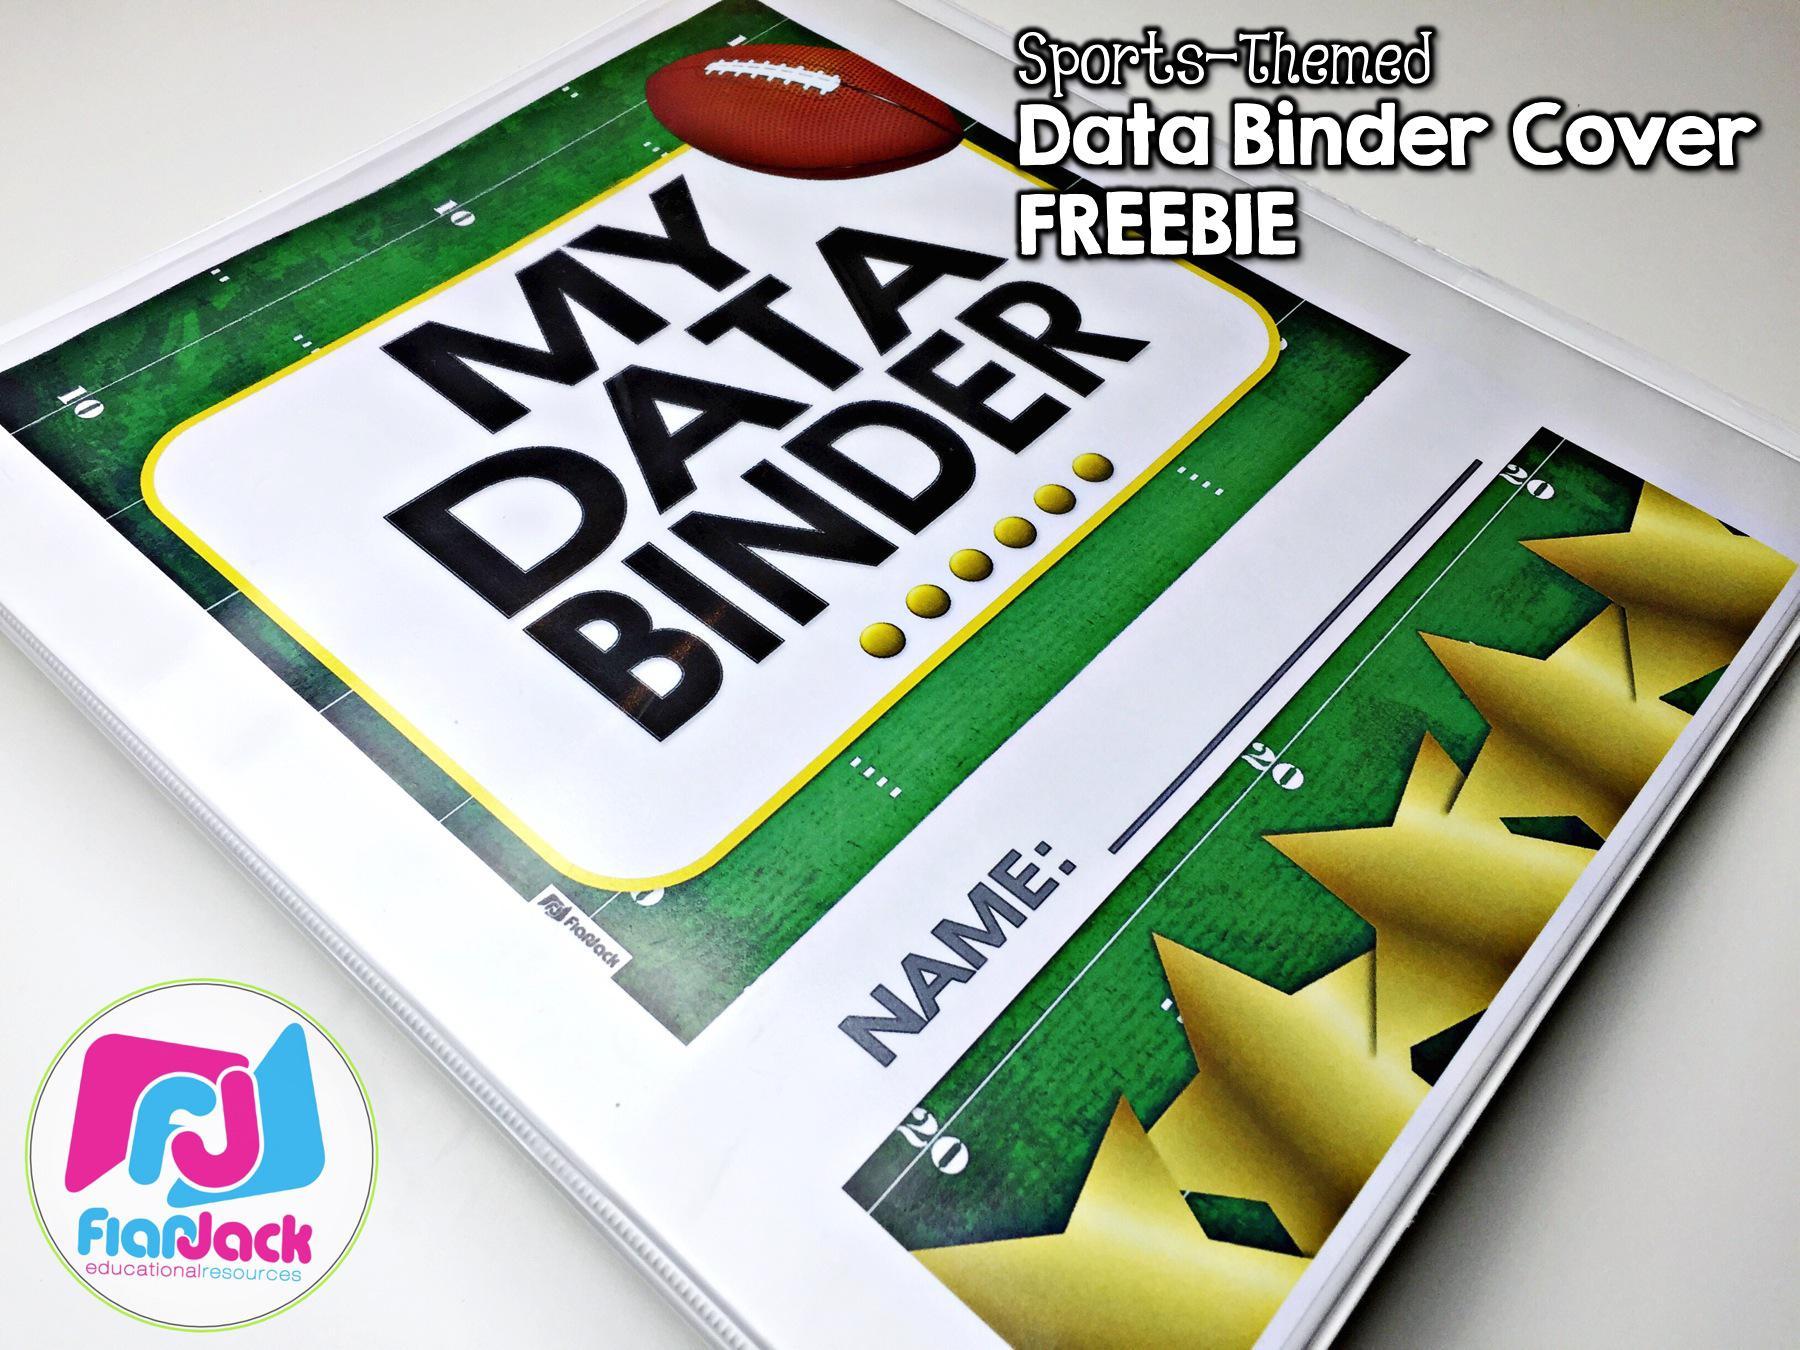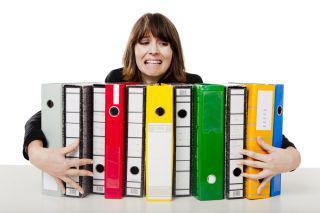The first image is the image on the left, the second image is the image on the right. For the images displayed, is the sentence "A person's arms wrap around a bunch of binders in one image." factually correct? Answer yes or no. Yes. The first image is the image on the left, the second image is the image on the right. Considering the images on both sides, is "A woman holds a pile of binders." valid? Answer yes or no. Yes. 